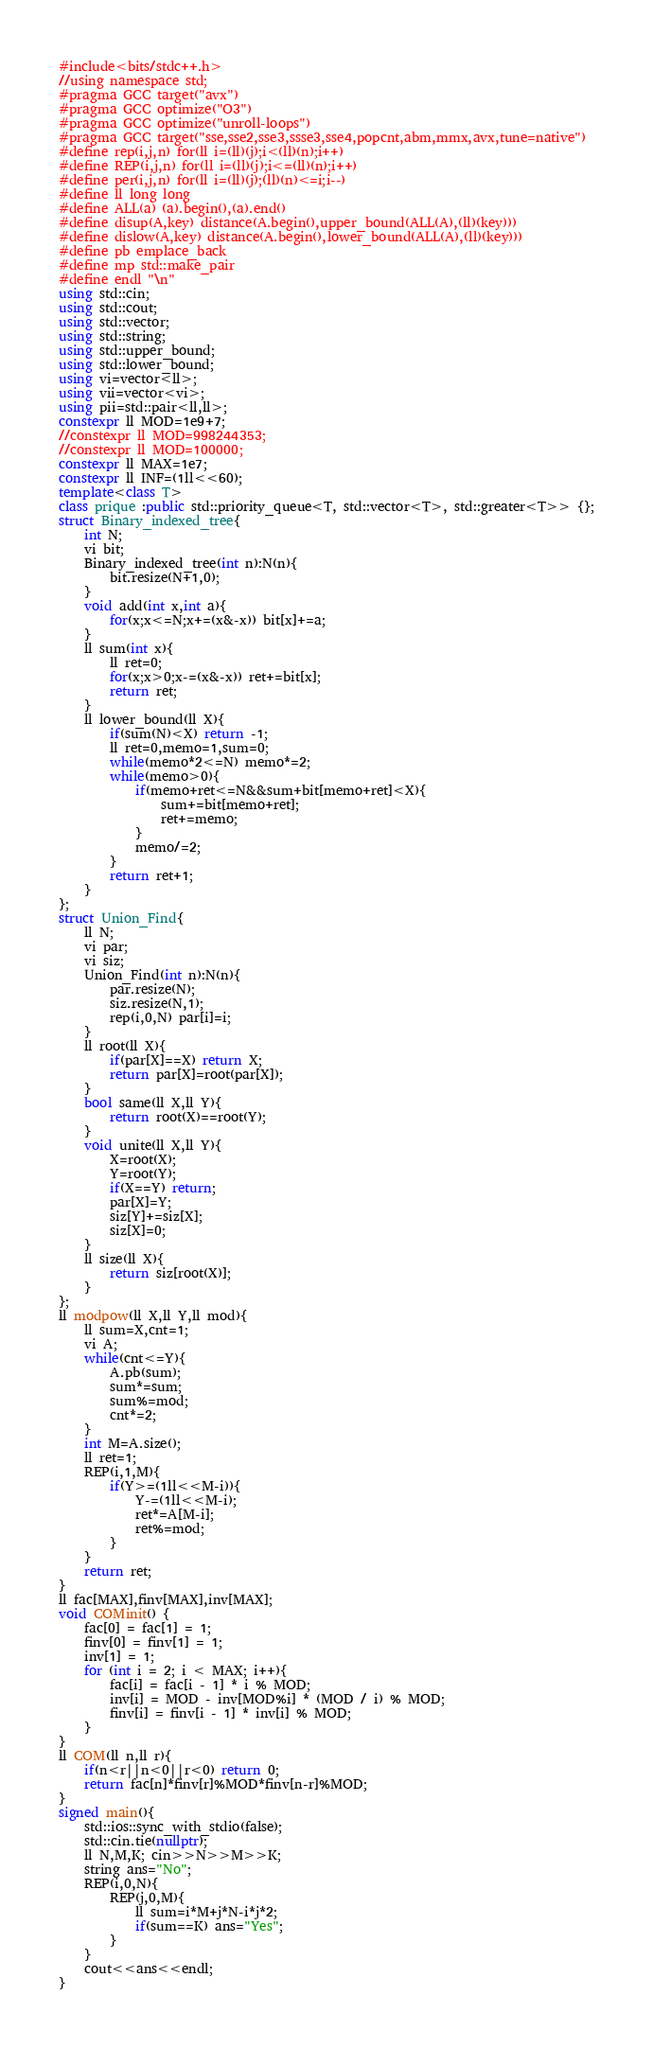<code> <loc_0><loc_0><loc_500><loc_500><_C++_>#include<bits/stdc++.h>
//using namespace std;
#pragma GCC target("avx")
#pragma GCC optimize("O3")
#pragma GCC optimize("unroll-loops")
#pragma GCC target("sse,sse2,sse3,ssse3,sse4,popcnt,abm,mmx,avx,tune=native")
#define rep(i,j,n) for(ll i=(ll)(j);i<(ll)(n);i++)
#define REP(i,j,n) for(ll i=(ll)(j);i<=(ll)(n);i++)
#define per(i,j,n) for(ll i=(ll)(j);(ll)(n)<=i;i--)
#define ll long long
#define ALL(a) (a).begin(),(a).end()
#define disup(A,key) distance(A.begin(),upper_bound(ALL(A),(ll)(key)))
#define dislow(A,key) distance(A.begin(),lower_bound(ALL(A),(ll)(key)))
#define pb emplace_back
#define mp std::make_pair
#define endl "\n"
using std::cin;
using std::cout;
using std::vector;
using std::string;
using std::upper_bound;
using std::lower_bound;
using vi=vector<ll>;
using vii=vector<vi>;
using pii=std::pair<ll,ll>;
constexpr ll MOD=1e9+7;
//constexpr ll MOD=998244353;
//constexpr ll MOD=100000;
constexpr ll MAX=1e7;
constexpr ll INF=(1ll<<60);
template<class T>
class prique :public std::priority_queue<T, std::vector<T>, std::greater<T>> {};
struct Binary_indexed_tree{
    int N;
    vi bit;
    Binary_indexed_tree(int n):N(n){
        bit.resize(N+1,0);
    }
    void add(int x,int a){
        for(x;x<=N;x+=(x&-x)) bit[x]+=a;
    }
    ll sum(int x){
        ll ret=0;
        for(x;x>0;x-=(x&-x)) ret+=bit[x];
        return ret;
    }
    ll lower_bound(ll X){
        if(sum(N)<X) return -1;
        ll ret=0,memo=1,sum=0;
        while(memo*2<=N) memo*=2;
        while(memo>0){
            if(memo+ret<=N&&sum+bit[memo+ret]<X){
                sum+=bit[memo+ret];
                ret+=memo;
            }
            memo/=2;
        }
        return ret+1;
    }
};
struct Union_Find{
    ll N;
    vi par;
    vi siz;
    Union_Find(int n):N(n){
        par.resize(N);
        siz.resize(N,1);
        rep(i,0,N) par[i]=i;
    }
    ll root(ll X){
        if(par[X]==X) return X;
        return par[X]=root(par[X]);
    }
    bool same(ll X,ll Y){
        return root(X)==root(Y);
    }
    void unite(ll X,ll Y){
        X=root(X);
        Y=root(Y);
        if(X==Y) return;
        par[X]=Y;
        siz[Y]+=siz[X];
        siz[X]=0;
    }
    ll size(ll X){
        return siz[root(X)];
    }
};
ll modpow(ll X,ll Y,ll mod){
    ll sum=X,cnt=1;
    vi A;
    while(cnt<=Y){
        A.pb(sum);
        sum*=sum;
        sum%=mod;
        cnt*=2;
    }
    int M=A.size();
    ll ret=1;
    REP(i,1,M){
        if(Y>=(1ll<<M-i)){
            Y-=(1ll<<M-i);
            ret*=A[M-i];
            ret%=mod;
        }
    }
    return ret;
}
ll fac[MAX],finv[MAX],inv[MAX];
void COMinit() {
    fac[0] = fac[1] = 1;
    finv[0] = finv[1] = 1;
    inv[1] = 1;
    for (int i = 2; i < MAX; i++){
        fac[i] = fac[i - 1] * i % MOD;
        inv[i] = MOD - inv[MOD%i] * (MOD / i) % MOD;
        finv[i] = finv[i - 1] * inv[i] % MOD;
    }
}
ll COM(ll n,ll r){
    if(n<r||n<0||r<0) return 0;
    return fac[n]*finv[r]%MOD*finv[n-r]%MOD;
}
signed main(){
    std::ios::sync_with_stdio(false);
    std::cin.tie(nullptr);
    ll N,M,K; cin>>N>>M>>K;
    string ans="No";
    REP(i,0,N){
        REP(j,0,M){
            ll sum=i*M+j*N-i*j*2;
            if(sum==K) ans="Yes";
        }
    }
    cout<<ans<<endl;
}</code> 